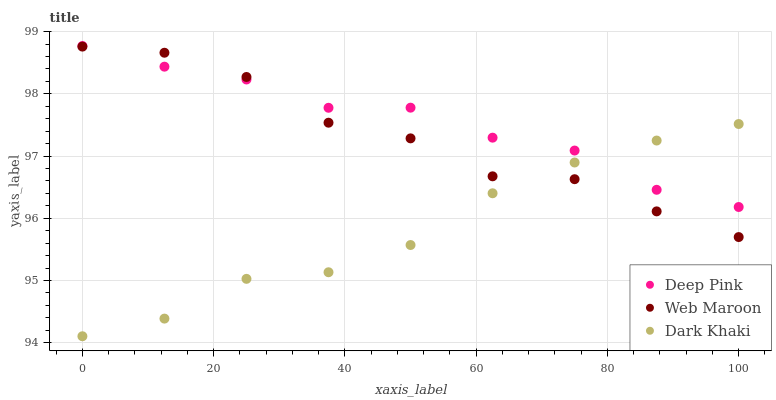Does Dark Khaki have the minimum area under the curve?
Answer yes or no. Yes. Does Deep Pink have the maximum area under the curve?
Answer yes or no. Yes. Does Web Maroon have the minimum area under the curve?
Answer yes or no. No. Does Web Maroon have the maximum area under the curve?
Answer yes or no. No. Is Dark Khaki the smoothest?
Answer yes or no. Yes. Is Web Maroon the roughest?
Answer yes or no. Yes. Is Deep Pink the smoothest?
Answer yes or no. No. Is Deep Pink the roughest?
Answer yes or no. No. Does Dark Khaki have the lowest value?
Answer yes or no. Yes. Does Web Maroon have the lowest value?
Answer yes or no. No. Does Deep Pink have the highest value?
Answer yes or no. Yes. Does Web Maroon have the highest value?
Answer yes or no. No. Does Dark Khaki intersect Deep Pink?
Answer yes or no. Yes. Is Dark Khaki less than Deep Pink?
Answer yes or no. No. Is Dark Khaki greater than Deep Pink?
Answer yes or no. No. 